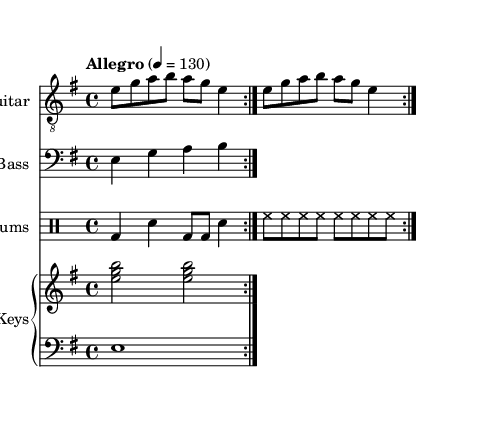What is the key signature of this music? The key signature is E minor, as indicated by the presence of one sharp (F#) in the key signature section.
Answer: E minor What is the time signature of this music? The time signature is 4/4, which is shown at the beginning of the score. This means there are four beats in each measure and the quarter note gets one beat.
Answer: 4/4 What is the tempo marking for this music? The tempo marking is "Allegro" with a metronome marking of quarter note equals 130, indicating a fast pace for the performance.
Answer: Allegro, 130 How many measures are repeated in the guitar part? The guitar part indicates a repeat sign and repeats twice, meaning the sequence is played twice in total.
Answer: 2 How is the bass part structured compared to the guitar part? The bass part consists of quarter notes that support the guitar by playing the root notes of the chords, reflecting a common rock style foundation, consisting of repeated phrases that mirror the guitar riff.
Answer: Repetitive supporting structure What is the predominant rhythm instrument used in this piece? The drums are prominent in rock music, providing a steady backbeat and dynamic drive. The score features a standard rock drum pattern consisting of bass and snare hits, which drive the rhythm.
Answer: Drums How many instruments are included in the score? The score features four distinct instruments: guitar, bass, drums, and keyboard. Each instrument has its own designated staff in the score, allowing for a full band arrangement typical of classic rock music.
Answer: 4 